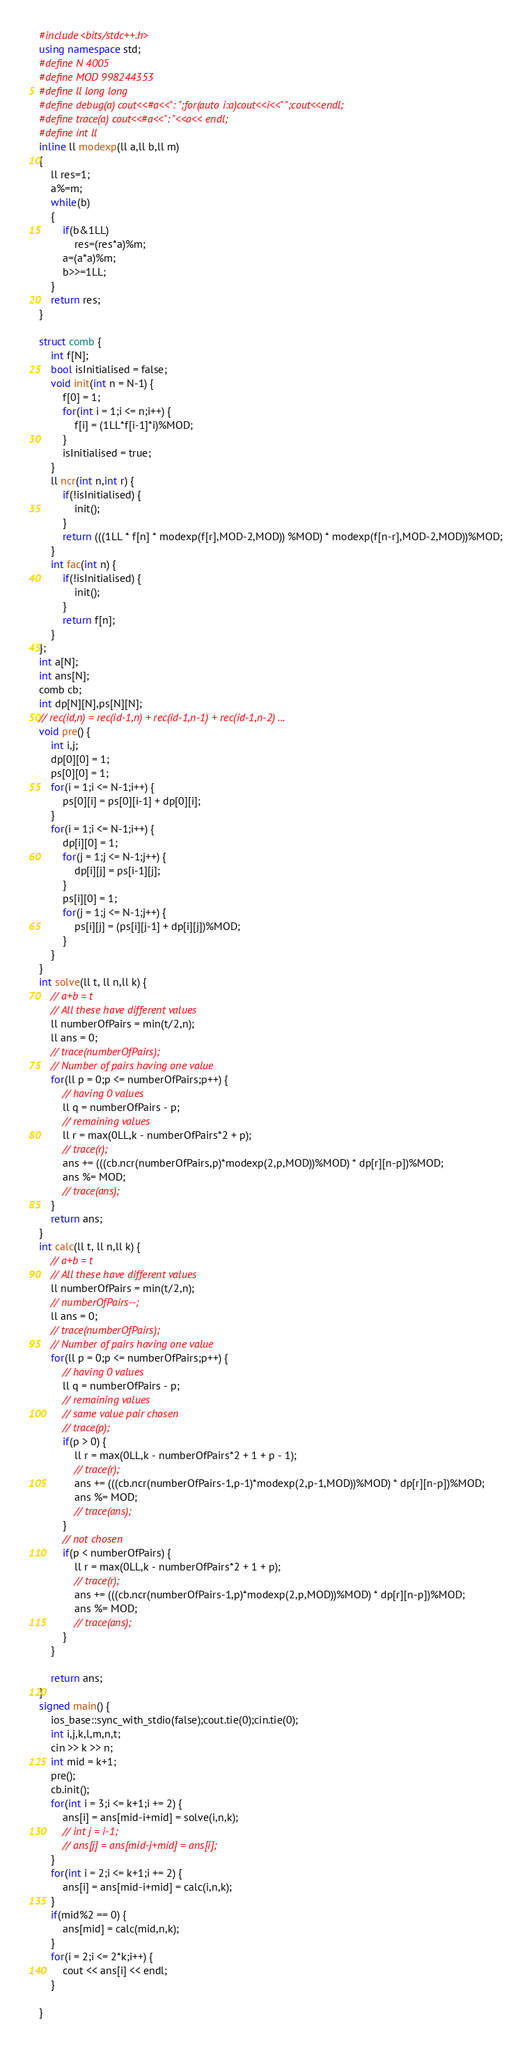Convert code to text. <code><loc_0><loc_0><loc_500><loc_500><_C++_>#include<bits/stdc++.h>
using namespace std;
#define N 4005
#define MOD 998244353
#define ll long long
#define debug(a) cout<<#a<<": ";for(auto i:a)cout<<i<<" ";cout<<endl;
#define trace(a) cout<<#a<<": "<<a<< endl;
#define int ll
inline ll modexp(ll a,ll b,ll m)
{
    ll res=1;
    a%=m;
    while(b)
    {
        if(b&1LL)
            res=(res*a)%m;
        a=(a*a)%m;
        b>>=1LL;
    }
    return res;
}

struct comb {
	int f[N];
	bool isInitialised = false;
	void init(int n = N-1) {
		f[0] = 1;
		for(int i = 1;i <= n;i++) {
			f[i] = (1LL*f[i-1]*i)%MOD;
		}
		isInitialised = true;
	}
	ll ncr(int n,int r) {
		if(!isInitialised) {
			init();
		}
		return (((1LL * f[n] * modexp(f[r],MOD-2,MOD)) %MOD) * modexp(f[n-r],MOD-2,MOD))%MOD;
	}
	int fac(int n) {
		if(!isInitialised) {
			init();
		}
		return f[n];
	}
};
int a[N];
int ans[N];
comb cb;
int dp[N][N],ps[N][N];
// rec(id,n) = rec(id-1,n) + rec(id-1,n-1) + rec(id-1,n-2) ...
void pre() {
	int i,j;
	dp[0][0] = 1;
	ps[0][0] = 1;
	for(i = 1;i <= N-1;i++) {
		ps[0][i] = ps[0][i-1] + dp[0][i];
	}
	for(i = 1;i <= N-1;i++) {
		dp[i][0] = 1;
		for(j = 1;j <= N-1;j++) {
			dp[i][j] = ps[i-1][j];
		}
		ps[i][0] = 1;
		for(j = 1;j <= N-1;j++) {
			ps[i][j] = (ps[i][j-1] + dp[i][j])%MOD;
		}
	}
}
int solve(ll t, ll n,ll k) {
	// a+b = t
	// All these have different values
	ll numberOfPairs = min(t/2,n);
	ll ans = 0;
	// trace(numberOfPairs);
	// Number of pairs having one value
	for(ll p = 0;p <= numberOfPairs;p++) {
		// having 0 values
		ll q = numberOfPairs - p;
		// remaining values
		ll r = max(0LL,k - numberOfPairs*2 + p);
		// trace(r);
		ans += (((cb.ncr(numberOfPairs,p)*modexp(2,p,MOD))%MOD) * dp[r][n-p])%MOD;
		ans %= MOD;
		// trace(ans);
	}
	return ans;
}
int calc(ll t, ll n,ll k) {
	// a+b = t
	// All these have different values
	ll numberOfPairs = min(t/2,n);
	// numberOfPairs--;
	ll ans = 0;
	// trace(numberOfPairs);
	// Number of pairs having one value
	for(ll p = 0;p <= numberOfPairs;p++) {
		// having 0 values
		ll q = numberOfPairs - p;
		// remaining values
		// same value pair chosen
		// trace(p);
		if(p > 0) {
			ll r = max(0LL,k - numberOfPairs*2 + 1 + p - 1);
			// trace(r);
			ans += (((cb.ncr(numberOfPairs-1,p-1)*modexp(2,p-1,MOD))%MOD) * dp[r][n-p])%MOD;
			ans %= MOD;
			// trace(ans);
		}
		// not chosen
		if(p < numberOfPairs) {
			ll r = max(0LL,k - numberOfPairs*2 + 1 + p);
			// trace(r);
			ans += (((cb.ncr(numberOfPairs-1,p)*modexp(2,p,MOD))%MOD) * dp[r][n-p])%MOD;
			ans %= MOD;
			// trace(ans);
		}
	}

	return ans;
}
signed main() {
	ios_base::sync_with_stdio(false);cout.tie(0);cin.tie(0);
	int i,j,k,l,m,n,t;
	cin >> k >> n;
	int mid = k+1;
	pre();
	cb.init();
	for(int i = 3;i <= k+1;i += 2) {
		ans[i] = ans[mid-i+mid] = solve(i,n,k);
		// int j = i-1;
		// ans[j] = ans[mid-j+mid] = ans[i];
	}
	for(int i = 2;i <= k+1;i += 2) {
		ans[i] = ans[mid-i+mid] = calc(i,n,k);
	}
	if(mid%2 == 0) {
		ans[mid] = calc(mid,n,k);
	}
	for(i = 2;i <= 2*k;i++) {
		cout << ans[i] << endl;
	}

}</code> 